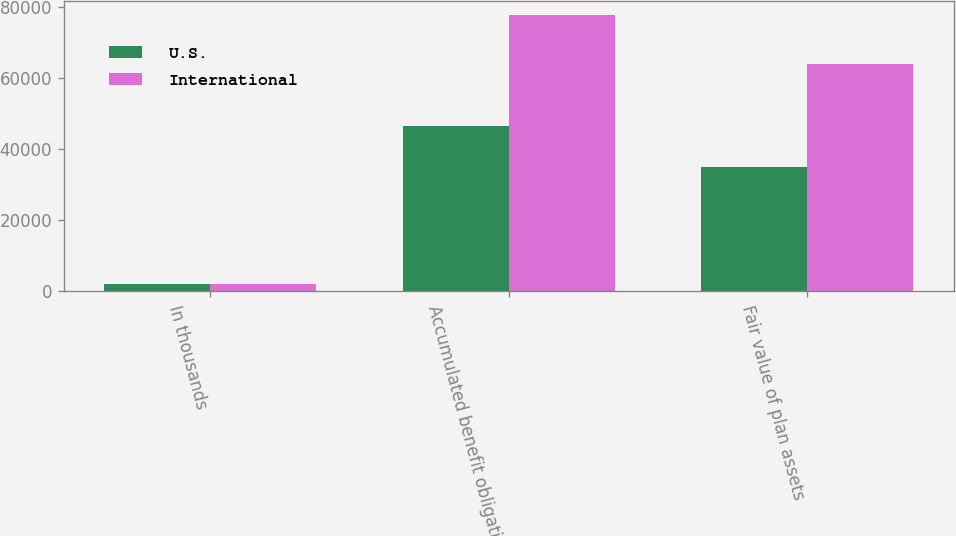Convert chart. <chart><loc_0><loc_0><loc_500><loc_500><stacked_bar_chart><ecel><fcel>In thousands<fcel>Accumulated benefit obligation<fcel>Fair value of plan assets<nl><fcel>U.S.<fcel>2009<fcel>46472<fcel>34872<nl><fcel>International<fcel>2009<fcel>77767<fcel>64105<nl></chart> 